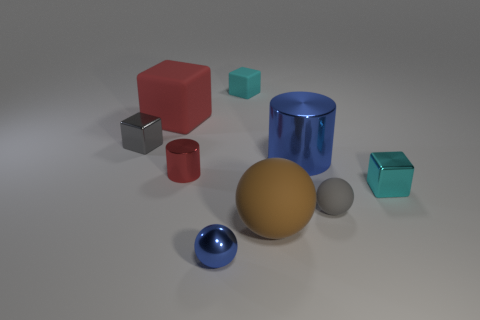Subtract all small cubes. How many cubes are left? 1 Subtract all brown balls. How many cyan cubes are left? 2 Subtract all red cylinders. How many cylinders are left? 1 Subtract 1 cubes. How many cubes are left? 3 Subtract all spheres. How many objects are left? 6 Subtract all blue spheres. Subtract all green blocks. How many spheres are left? 2 Add 7 big red cubes. How many big red cubes exist? 8 Subtract 1 red cylinders. How many objects are left? 8 Subtract all tiny green spheres. Subtract all tiny blue things. How many objects are left? 8 Add 3 small metallic things. How many small metallic things are left? 7 